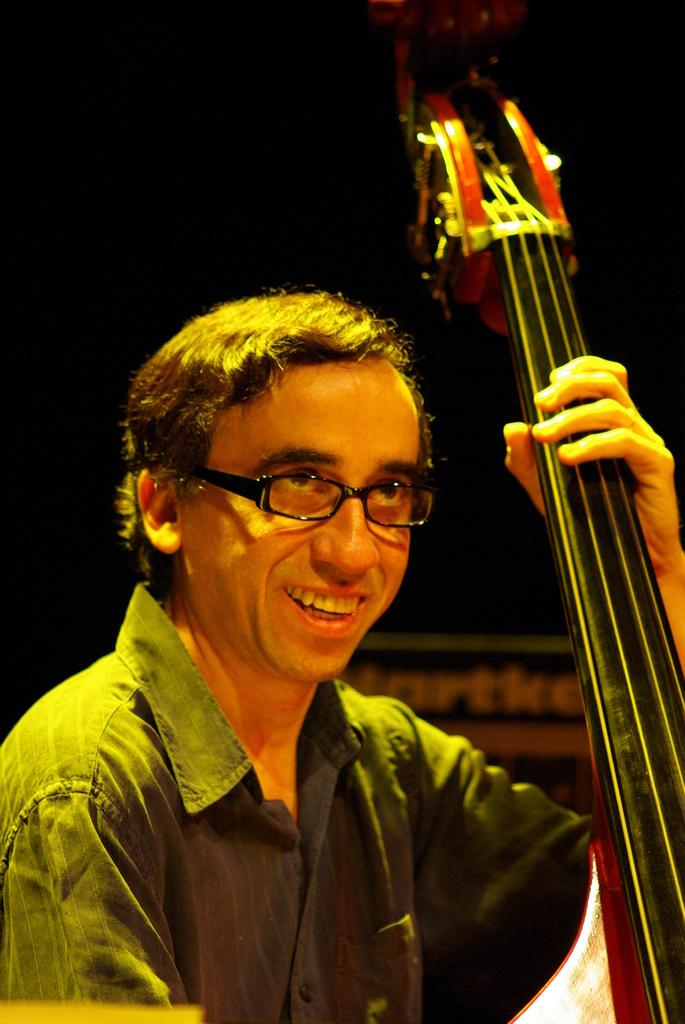Who is present in the image? There is a man in the image. What is the man doing in the image? The man is smiling and holding a musical instrument. How would you describe the lighting in the image? The background of the image appears dark. What type of exchange is taking place in the field to the north of the image? There is no field or exchange present in the image; it features a man holding a musical instrument against a dark background. 